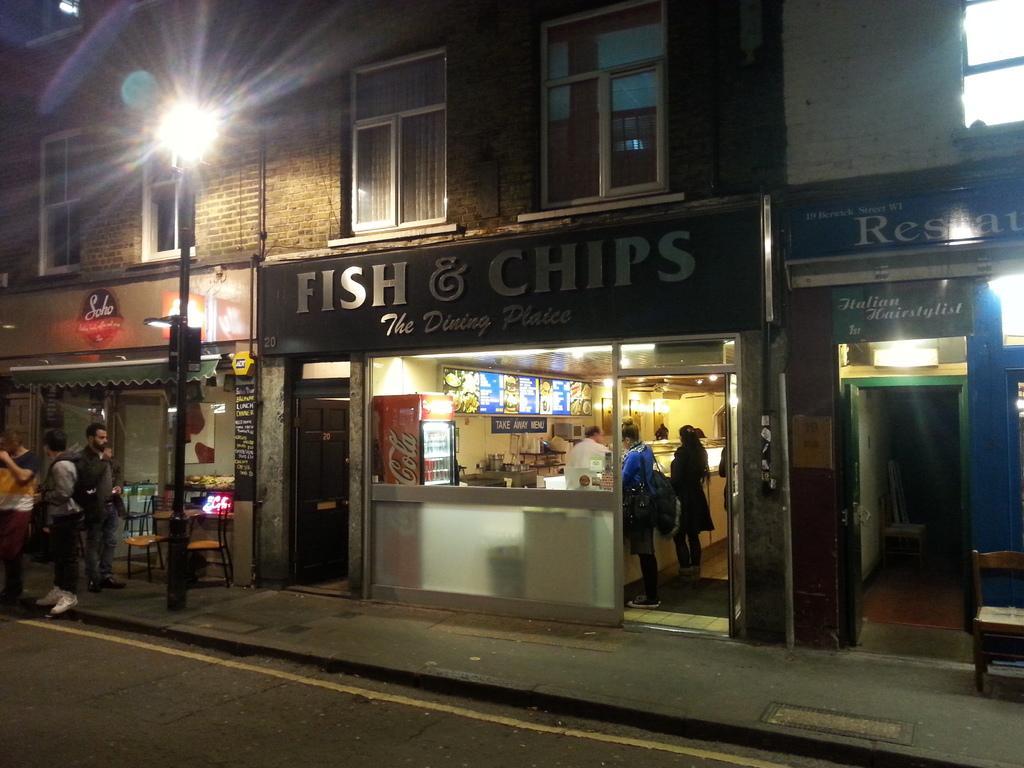Describe this image in one or two sentences. In this image I can see buildings, windows, hoardings, stores, people, chairs, tables, light pole, fridge, display, boards, doors, lights and objects.   